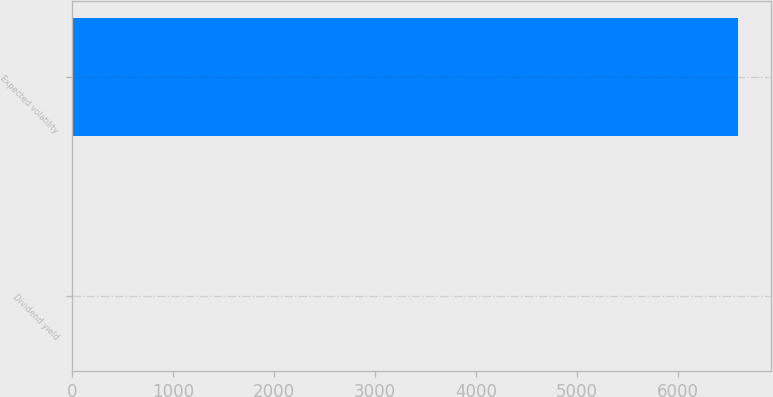Convert chart to OTSL. <chart><loc_0><loc_0><loc_500><loc_500><bar_chart><fcel>Dividend yield<fcel>Expected volatility<nl><fcel>1.34<fcel>6589<nl></chart> 